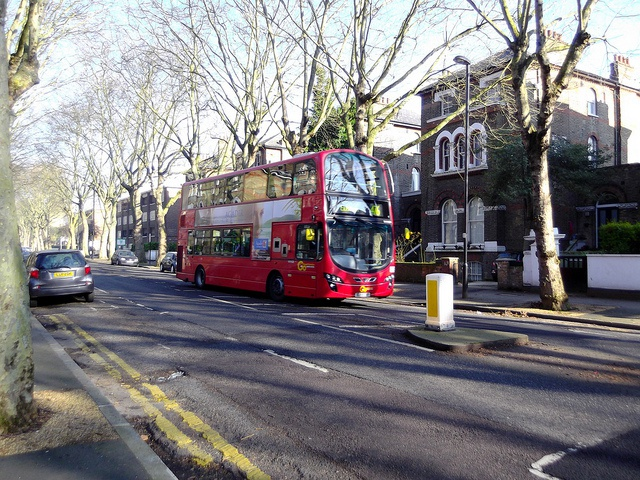Describe the objects in this image and their specific colors. I can see bus in gray, maroon, black, and darkgray tones, car in gray, darkgray, and navy tones, car in gray, darkgray, and lightgray tones, and car in gray, black, and darkgray tones in this image. 